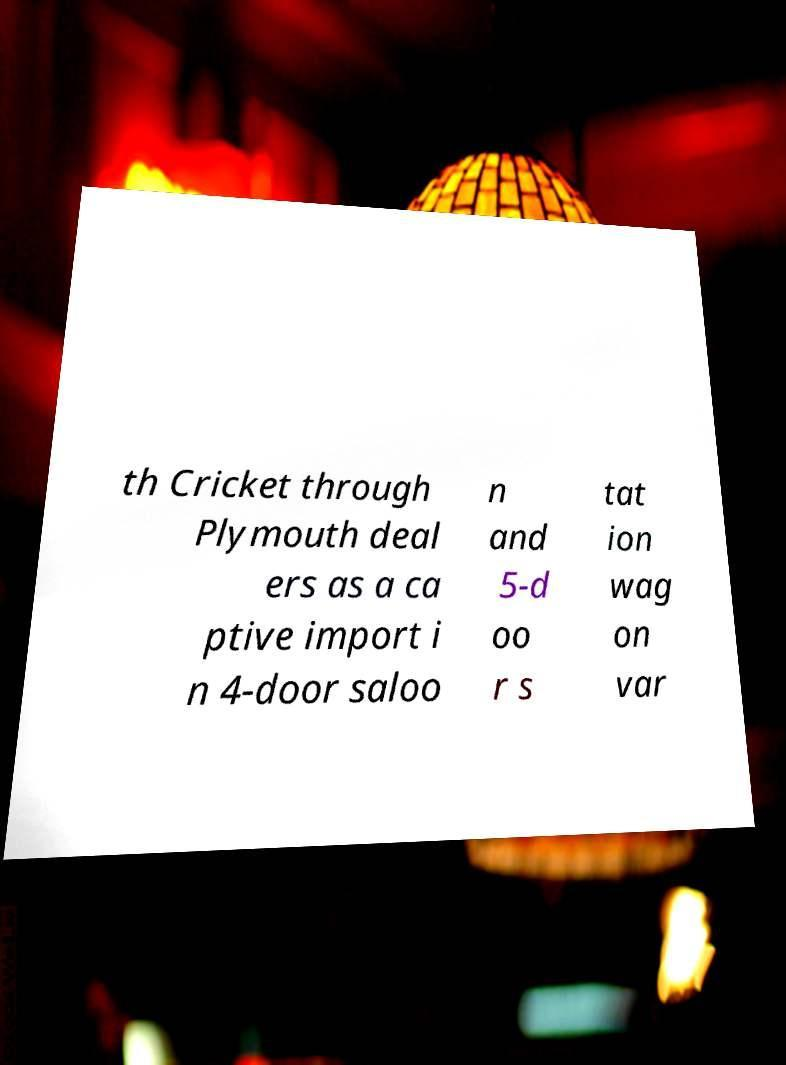For documentation purposes, I need the text within this image transcribed. Could you provide that? th Cricket through Plymouth deal ers as a ca ptive import i n 4-door saloo n and 5-d oo r s tat ion wag on var 